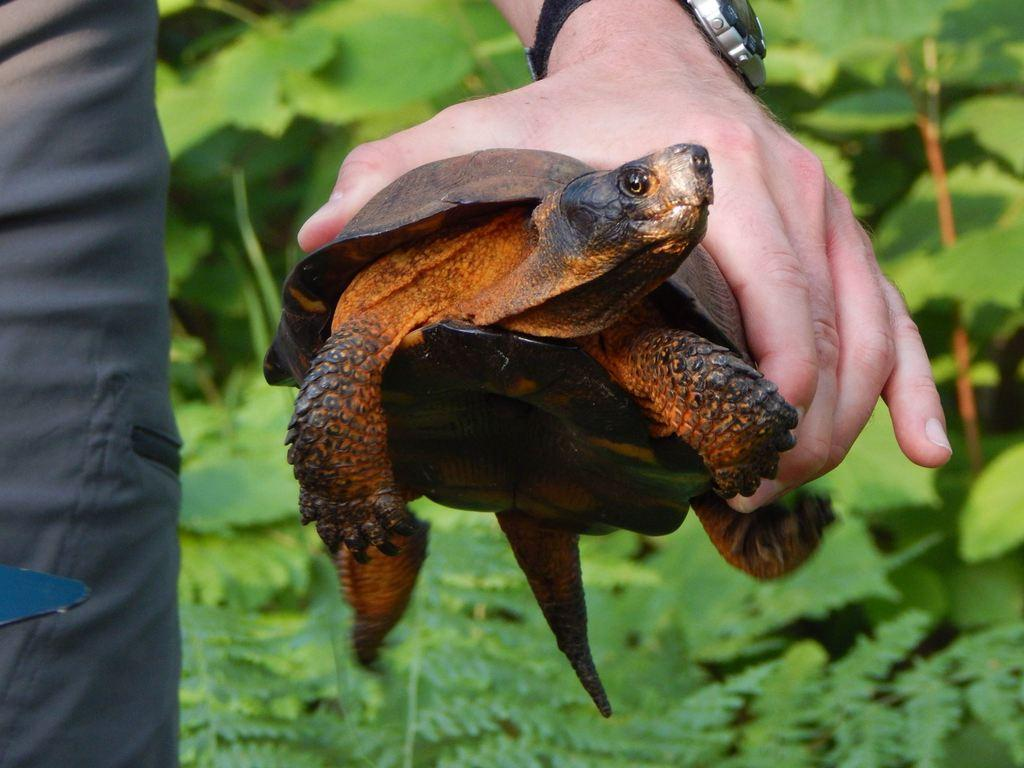What is the person holding in the image? The person is holding a tortoise in the image. What accessory can be seen on the person's wrist? The person is wearing a watch on their wrist. Can you describe any body part of the person besides their hand and wrist? There is a leg of a person visible in the image. What can be seen in the background of the image? There are plants in the background of the image. Where is the shelf located in the image? There is no shelf present in the image. What type of flesh can be seen on the tortoise in the image? The image does not show any flesh on the tortoise; it only shows the tortoise's shell. 